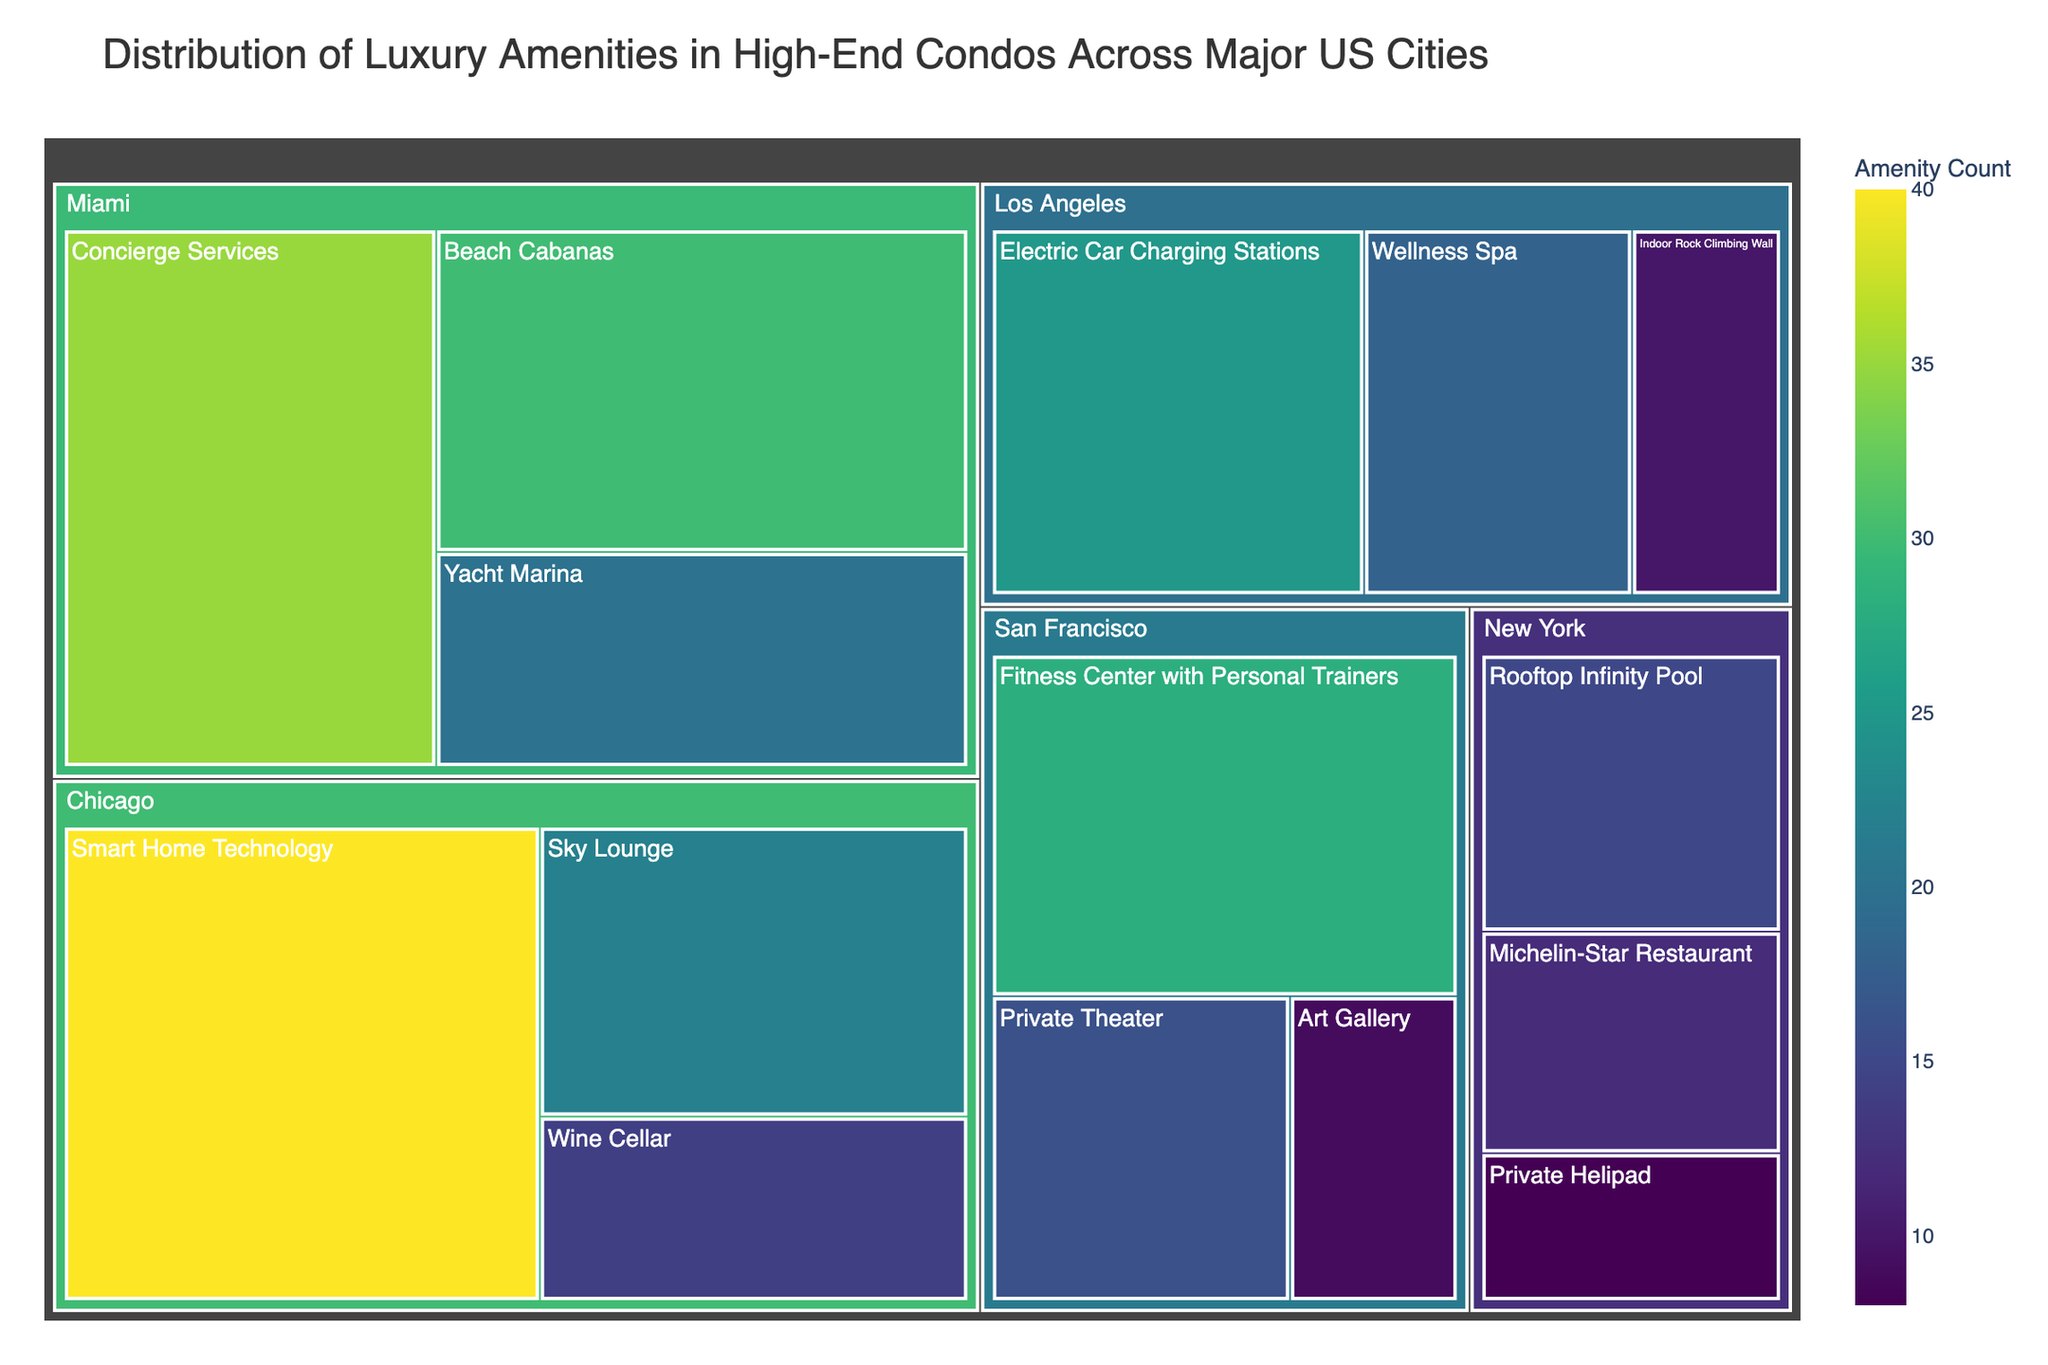What is the title of the treemap? The title of the treemap is located at the top of the figure and summarizes what the visualization is about.
Answer: Distribution of Luxury Amenities in High-End Condos Across Major US Cities Which city has the most numerous luxury amenity options based on the size and color of the boxes in the treemap? The city with the largest and darkest colored boxes indicates the most numerous amenities.
Answer: Miami How many rooftop infinity pools are in New York? Locate the section for New York and find the box labeled "Rooftop Infinity Pool" to see the count.
Answer: 15 Which amenity in Miami has the highest count? Within the Miami section, look for the amenity with the largest box.
Answer: Concierge Services What is the combined total of amenities counted in Los Angeles? Sum the counts of all amenities listed under Los Angeles: Indoor Rock Climbing Wall (10) + Wellness Spa (18) + Electric Car Charging Stations (25).
Answer: 53 Which two cities have more than one amenity option exceeding the count of 20? Identify the cities and then check which amenities exceed the count of 20.
Answer: Chicago and San Francisco Is the count of Private Theaters in San Francisco greater than the count of Private Helipads in New York? Compare the counts of Private Theater (16) in San Francisco and Private Helipad (8) in New York.
Answer: Yes What is the difference in the number of Art Galleries in San Francisco compared to Michelin-Star Restaurants in New York? Subtract the count of Art Galleries (9) in San Francisco from the count of Michelin-Star Restaurants (12) in New York.
Answer: 3 What is the total number of amenities available in Chicago? Add the counts of all amenities listed under Chicago: Sky Lounge (22) + Wine Cellar (14) + Smart Home Technology (40).
Answer: 76 Which city has the amenity with the highest individual count and what is that count? Find the amenity with the largest count across all cities.
Answer: San Francisco, Smart Home Technology, 40 